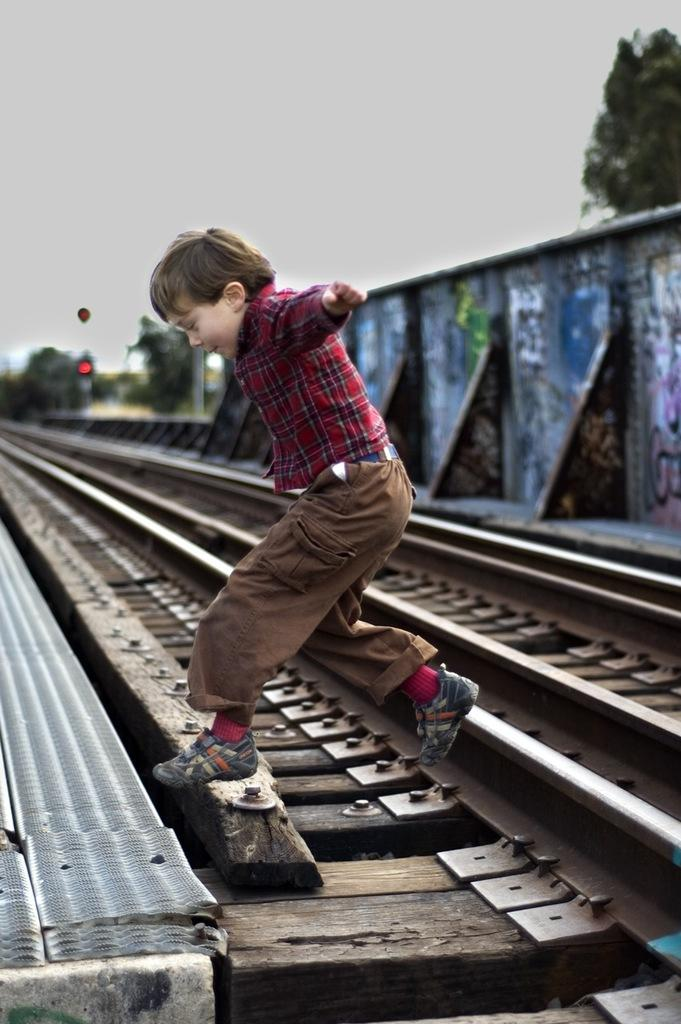What is the boy in the image doing? The boy is in the air, looking downwards. What can be seen on the ground in the image? The image contains train tracks. How would you describe the background of the image? The background is blurred. What structures are visible in the background? There is a wall and a signal light in the background. What type of vegetation is present in the background? Trees are present in the background. How many girls are holding a cent in the image? There are no girls or cents present in the image. What type of answer is the boy providing in the image? The image does not show the boy providing any answer; he is simply looking downwards. 